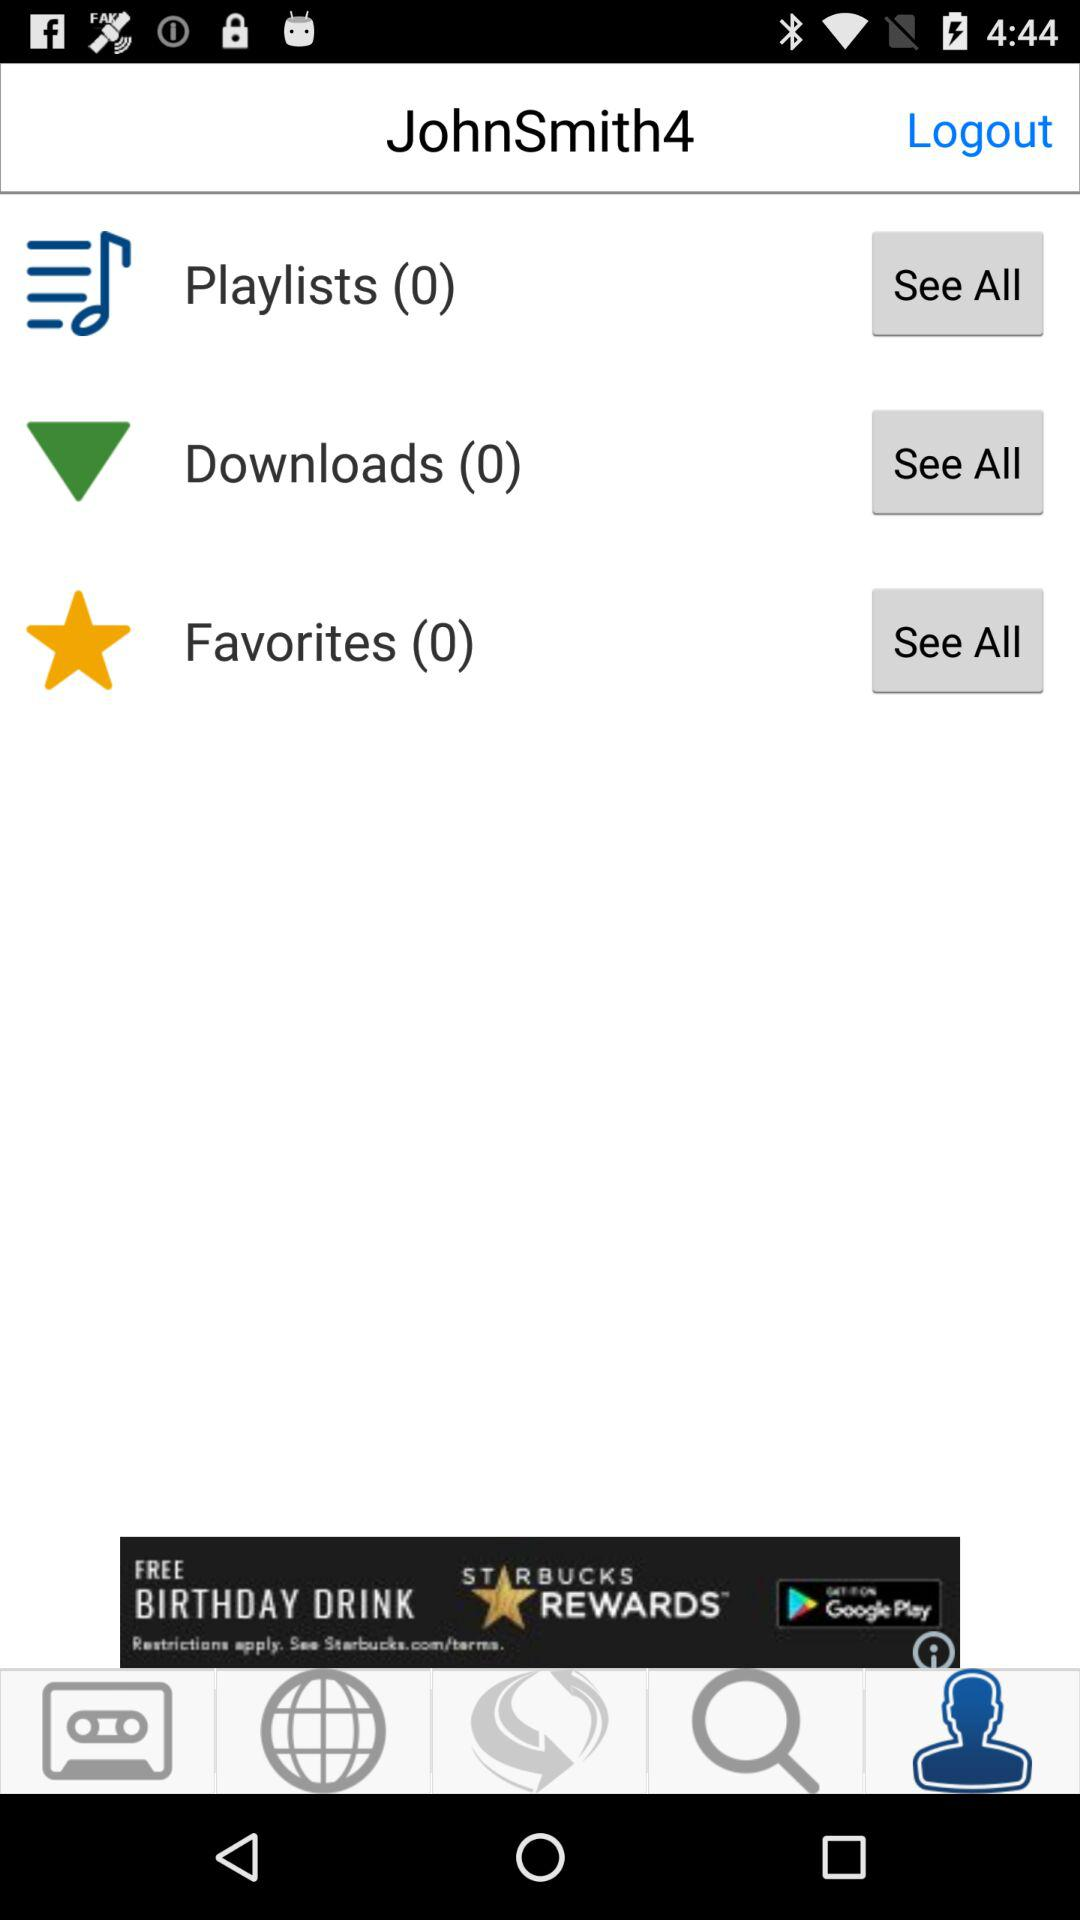How many items have a number in their text?
Answer the question using a single word or phrase. 3 